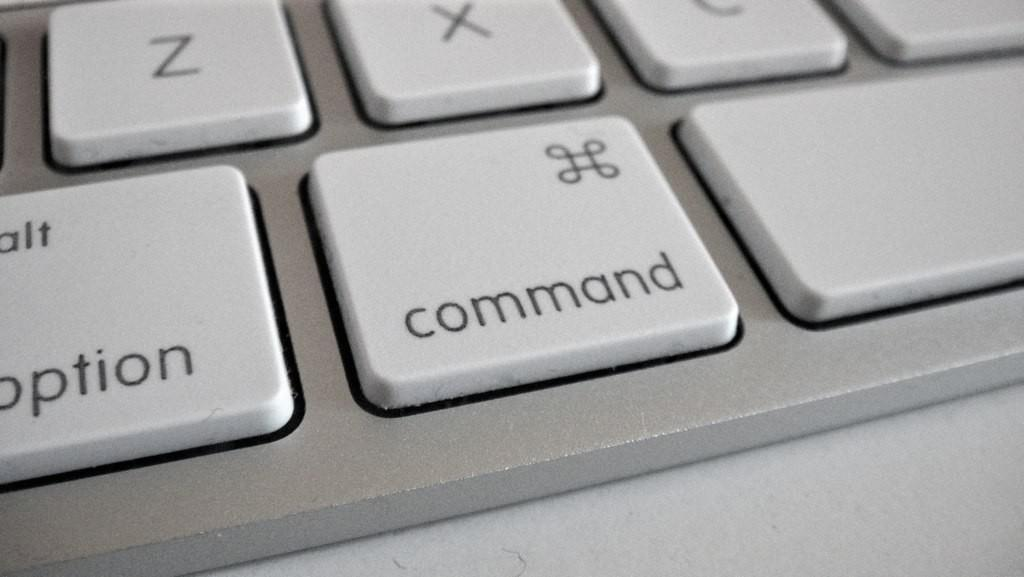<image>
Summarize the visual content of the image. a close up of a computer keyboard Command Key 